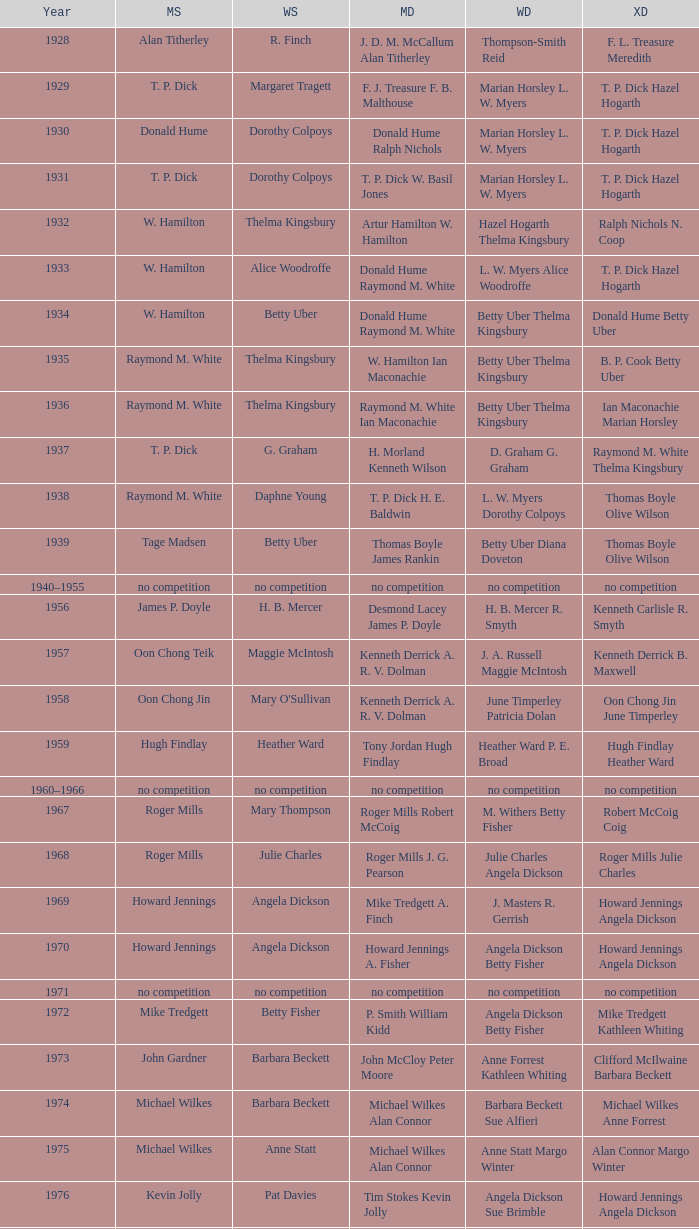Who were the victors in the women's doubles during the year billy gilliland and karen puttick triumphed in the mixed doubles? Jane Webster Karen Puttick. Parse the full table. {'header': ['Year', 'MS', 'WS', 'MD', 'WD', 'XD'], 'rows': [['1928', 'Alan Titherley', 'R. Finch', 'J. D. M. McCallum Alan Titherley', 'Thompson-Smith Reid', 'F. L. Treasure Meredith'], ['1929', 'T. P. Dick', 'Margaret Tragett', 'F. J. Treasure F. B. Malthouse', 'Marian Horsley L. W. Myers', 'T. P. Dick Hazel Hogarth'], ['1930', 'Donald Hume', 'Dorothy Colpoys', 'Donald Hume Ralph Nichols', 'Marian Horsley L. W. Myers', 'T. P. Dick Hazel Hogarth'], ['1931', 'T. P. Dick', 'Dorothy Colpoys', 'T. P. Dick W. Basil Jones', 'Marian Horsley L. W. Myers', 'T. P. Dick Hazel Hogarth'], ['1932', 'W. Hamilton', 'Thelma Kingsbury', 'Artur Hamilton W. Hamilton', 'Hazel Hogarth Thelma Kingsbury', 'Ralph Nichols N. Coop'], ['1933', 'W. Hamilton', 'Alice Woodroffe', 'Donald Hume Raymond M. White', 'L. W. Myers Alice Woodroffe', 'T. P. Dick Hazel Hogarth'], ['1934', 'W. Hamilton', 'Betty Uber', 'Donald Hume Raymond M. White', 'Betty Uber Thelma Kingsbury', 'Donald Hume Betty Uber'], ['1935', 'Raymond M. White', 'Thelma Kingsbury', 'W. Hamilton Ian Maconachie', 'Betty Uber Thelma Kingsbury', 'B. P. Cook Betty Uber'], ['1936', 'Raymond M. White', 'Thelma Kingsbury', 'Raymond M. White Ian Maconachie', 'Betty Uber Thelma Kingsbury', 'Ian Maconachie Marian Horsley'], ['1937', 'T. P. Dick', 'G. Graham', 'H. Morland Kenneth Wilson', 'D. Graham G. Graham', 'Raymond M. White Thelma Kingsbury'], ['1938', 'Raymond M. White', 'Daphne Young', 'T. P. Dick H. E. Baldwin', 'L. W. Myers Dorothy Colpoys', 'Thomas Boyle Olive Wilson'], ['1939', 'Tage Madsen', 'Betty Uber', 'Thomas Boyle James Rankin', 'Betty Uber Diana Doveton', 'Thomas Boyle Olive Wilson'], ['1940–1955', 'no competition', 'no competition', 'no competition', 'no competition', 'no competition'], ['1956', 'James P. Doyle', 'H. B. Mercer', 'Desmond Lacey James P. Doyle', 'H. B. Mercer R. Smyth', 'Kenneth Carlisle R. Smyth'], ['1957', 'Oon Chong Teik', 'Maggie McIntosh', 'Kenneth Derrick A. R. V. Dolman', 'J. A. Russell Maggie McIntosh', 'Kenneth Derrick B. Maxwell'], ['1958', 'Oon Chong Jin', "Mary O'Sullivan", 'Kenneth Derrick A. R. V. Dolman', 'June Timperley Patricia Dolan', 'Oon Chong Jin June Timperley'], ['1959', 'Hugh Findlay', 'Heather Ward', 'Tony Jordan Hugh Findlay', 'Heather Ward P. E. Broad', 'Hugh Findlay Heather Ward'], ['1960–1966', 'no competition', 'no competition', 'no competition', 'no competition', 'no competition'], ['1967', 'Roger Mills', 'Mary Thompson', 'Roger Mills Robert McCoig', 'M. Withers Betty Fisher', 'Robert McCoig Coig'], ['1968', 'Roger Mills', 'Julie Charles', 'Roger Mills J. G. Pearson', 'Julie Charles Angela Dickson', 'Roger Mills Julie Charles'], ['1969', 'Howard Jennings', 'Angela Dickson', 'Mike Tredgett A. Finch', 'J. Masters R. Gerrish', 'Howard Jennings Angela Dickson'], ['1970', 'Howard Jennings', 'Angela Dickson', 'Howard Jennings A. Fisher', 'Angela Dickson Betty Fisher', 'Howard Jennings Angela Dickson'], ['1971', 'no competition', 'no competition', 'no competition', 'no competition', 'no competition'], ['1972', 'Mike Tredgett', 'Betty Fisher', 'P. Smith William Kidd', 'Angela Dickson Betty Fisher', 'Mike Tredgett Kathleen Whiting'], ['1973', 'John Gardner', 'Barbara Beckett', 'John McCloy Peter Moore', 'Anne Forrest Kathleen Whiting', 'Clifford McIlwaine Barbara Beckett'], ['1974', 'Michael Wilkes', 'Barbara Beckett', 'Michael Wilkes Alan Connor', 'Barbara Beckett Sue Alfieri', 'Michael Wilkes Anne Forrest'], ['1975', 'Michael Wilkes', 'Anne Statt', 'Michael Wilkes Alan Connor', 'Anne Statt Margo Winter', 'Alan Connor Margo Winter'], ['1976', 'Kevin Jolly', 'Pat Davies', 'Tim Stokes Kevin Jolly', 'Angela Dickson Sue Brimble', 'Howard Jennings Angela Dickson'], ['1977', 'David Eddy', 'Paula Kilvington', 'David Eddy Eddy Sutton', 'Anne Statt Jane Webster', 'David Eddy Barbara Giles'], ['1978', 'Mike Tredgett', 'Gillian Gilks', 'David Eddy Eddy Sutton', 'Barbara Sutton Marjan Ridder', 'Elliot Stuart Gillian Gilks'], ['1979', 'Kevin Jolly', 'Nora Perry', 'Ray Stevens Mike Tredgett', 'Barbara Sutton Nora Perry', 'Mike Tredgett Nora Perry'], ['1980', 'Thomas Kihlström', 'Jane Webster', 'Thomas Kihlström Bengt Fröman', 'Jane Webster Karen Puttick', 'Billy Gilliland Karen Puttick'], ['1981', 'Ray Stevens', 'Gillian Gilks', 'Ray Stevens Mike Tredgett', 'Gillian Gilks Paula Kilvington', 'Mike Tredgett Nora Perry'], ['1982', 'Steve Baddeley', 'Karen Bridge', 'David Eddy Eddy Sutton', 'Karen Chapman Sally Podger', 'Billy Gilliland Karen Chapman'], ['1983', 'Steve Butler', 'Sally Podger', 'Mike Tredgett Dipak Tailor', 'Nora Perry Jane Webster', 'Dipak Tailor Nora Perry'], ['1984', 'Steve Butler', 'Karen Beckman', 'Mike Tredgett Martin Dew', 'Helen Troke Karen Chapman', 'Mike Tredgett Karen Chapman'], ['1985', 'Morten Frost', 'Charlotte Hattens', 'Billy Gilliland Dan Travers', 'Gillian Gilks Helen Troke', 'Martin Dew Gillian Gilks'], ['1986', 'Darren Hall', 'Fiona Elliott', 'Martin Dew Dipak Tailor', 'Karen Beckman Sara Halsall', 'Jesper Knudsen Nettie Nielsen'], ['1987', 'Darren Hall', 'Fiona Elliott', 'Martin Dew Darren Hall', 'Karen Beckman Sara Halsall', 'Martin Dew Gillian Gilks'], ['1988', 'Vimal Kumar', 'Lee Jung-mi', 'Richard Outterside Mike Brown', 'Fiona Elliott Sara Halsall', 'Martin Dew Gillian Gilks'], ['1989', 'Darren Hall', 'Bang Soo-hyun', 'Nick Ponting Dave Wright', 'Karen Beckman Sara Sankey', 'Mike Brown Jillian Wallwork'], ['1990', 'Mathew Smith', 'Joanne Muggeridge', 'Nick Ponting Dave Wright', 'Karen Chapman Sara Sankey', 'Dave Wright Claire Palmer'], ['1991', 'Vimal Kumar', 'Denyse Julien', 'Nick Ponting Dave Wright', 'Cheryl Johnson Julie Bradbury', 'Nick Ponting Joanne Wright'], ['1992', 'Wei Yan', 'Fiona Smith', 'Michael Adams Chris Rees', 'Denyse Julien Doris Piché', 'Andy Goode Joanne Wright'], ['1993', 'Anders Nielsen', 'Sue Louis Lane', 'Nick Ponting Dave Wright', 'Julie Bradbury Sara Sankey', 'Nick Ponting Joanne Wright'], ['1994', 'Darren Hall', 'Marina Andrievskaya', 'Michael Adams Simon Archer', 'Julie Bradbury Joanne Wright', 'Chris Hunt Joanne Wright'], ['1995', 'Peter Rasmussen', 'Denyse Julien', 'Andrei Andropov Nikolai Zuyev', 'Julie Bradbury Joanne Wright', 'Nick Ponting Joanne Wright'], ['1996', 'Colin Haughton', 'Elena Rybkina', 'Andrei Andropov Nikolai Zuyev', 'Elena Rybkina Marina Yakusheva', 'Nikolai Zuyev Marina Yakusheva'], ['1997', 'Chris Bruil', 'Kelly Morgan', 'Ian Pearson James Anderson', 'Nicole van Hooren Brenda Conijn', 'Quinten van Dalm Nicole van Hooren'], ['1998', 'Dicky Palyama', 'Brenda Beenhakker', 'James Anderson Ian Sullivan', 'Sara Sankey Ella Tripp', 'James Anderson Sara Sankey'], ['1999', 'Daniel Eriksson', 'Marina Andrievskaya', 'Joachim Tesche Jean-Philippe Goyette', 'Marina Andrievskaya Catrine Bengtsson', 'Henrik Andersson Marina Andrievskaya'], ['2000', 'Richard Vaughan', 'Marina Yakusheva', 'Joachim Andersson Peter Axelsson', 'Irina Ruslyakova Marina Yakusheva', 'Peter Jeffrey Joanne Davies'], ['2001', 'Irwansyah', 'Brenda Beenhakker', 'Vincent Laigle Svetoslav Stoyanov', 'Sara Sankey Ella Tripp', 'Nikolai Zuyev Marina Yakusheva'], ['2002', 'Irwansyah', 'Karina de Wit', 'Nikolai Zuyev Stanislav Pukhov', 'Ella Tripp Joanne Wright', 'Nikolai Zuyev Marina Yakusheva'], ['2003', 'Irwansyah', 'Ella Karachkova', 'Ashley Thilthorpe Kristian Roebuck', 'Ella Karachkova Anastasia Russkikh', 'Alexandr Russkikh Anastasia Russkikh'], ['2004', 'Nathan Rice', 'Petya Nedelcheva', 'Reuben Gordown Aji Basuki Sindoro', 'Petya Nedelcheva Yuan Wemyss', 'Matthew Hughes Kelly Morgan'], ['2005', 'Chetan Anand', 'Eleanor Cox', 'Andrew Ellis Dean George', 'Hayley Connor Heather Olver', 'Valiyaveetil Diju Jwala Gutta'], ['2006', 'Irwansyah', 'Huang Chia-chi', 'Matthew Hughes Martyn Lewis', 'Natalie Munt Mariana Agathangelou', 'Kristian Roebuck Natalie Munt'], ['2007', 'Marc Zwiebler', 'Jill Pittard', 'Wojciech Szkudlarczyk Adam Cwalina', 'Chloe Magee Bing Huang', 'Wojciech Szkudlarczyk Malgorzata Kurdelska'], ['2008', 'Brice Leverdez', 'Kati Tolmoff', 'Andrew Bowman Martyn Lewis', 'Mariana Agathangelou Jillie Cooper', 'Watson Briggs Jillie Cooper'], ['2009', 'Kristian Nielsen', 'Tatjana Bibik', 'Vitaliy Durkin Alexandr Nikolaenko', 'Valeria Sorokina Nina Vislova', 'Vitaliy Durkin Nina Vislova'], ['2010', 'Pablo Abián', 'Anita Raj Kaur', 'Peter Käsbauer Josche Zurwonne', 'Joanne Quay Swee Ling Anita Raj Kaur', 'Peter Käsbauer Johanna Goliszewski'], ['2011', 'Niluka Karunaratne', 'Nicole Schaller', 'Chris Coles Matthew Nottingham', 'Ng Hui Ern Ng Hui Lin', 'Martin Campbell Ng Hui Lin'], ['2012', 'Chou Tien-chen', 'Chiang Mei-hui', 'Marcus Ellis Paul Van Rietvelde', 'Gabrielle White Lauren Smith', 'Marcus Ellis Gabrielle White']]} 